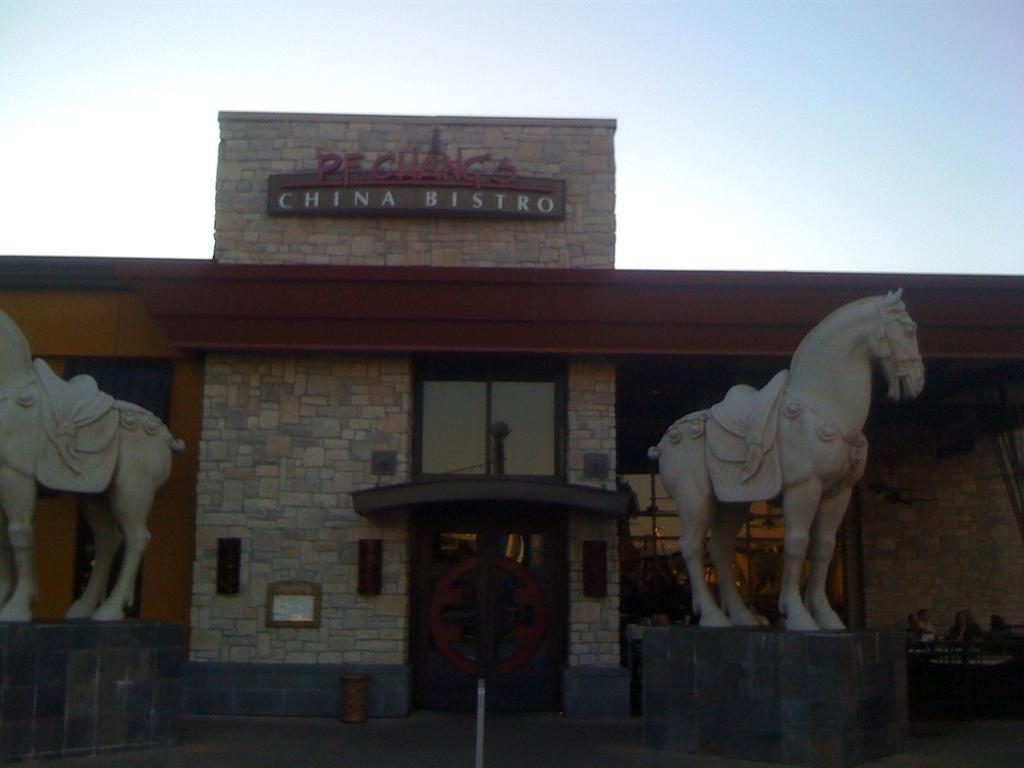Can you describe this image briefly? In the center of the image there is a building. There are depictions of horses. At the top of the image there is sky. 